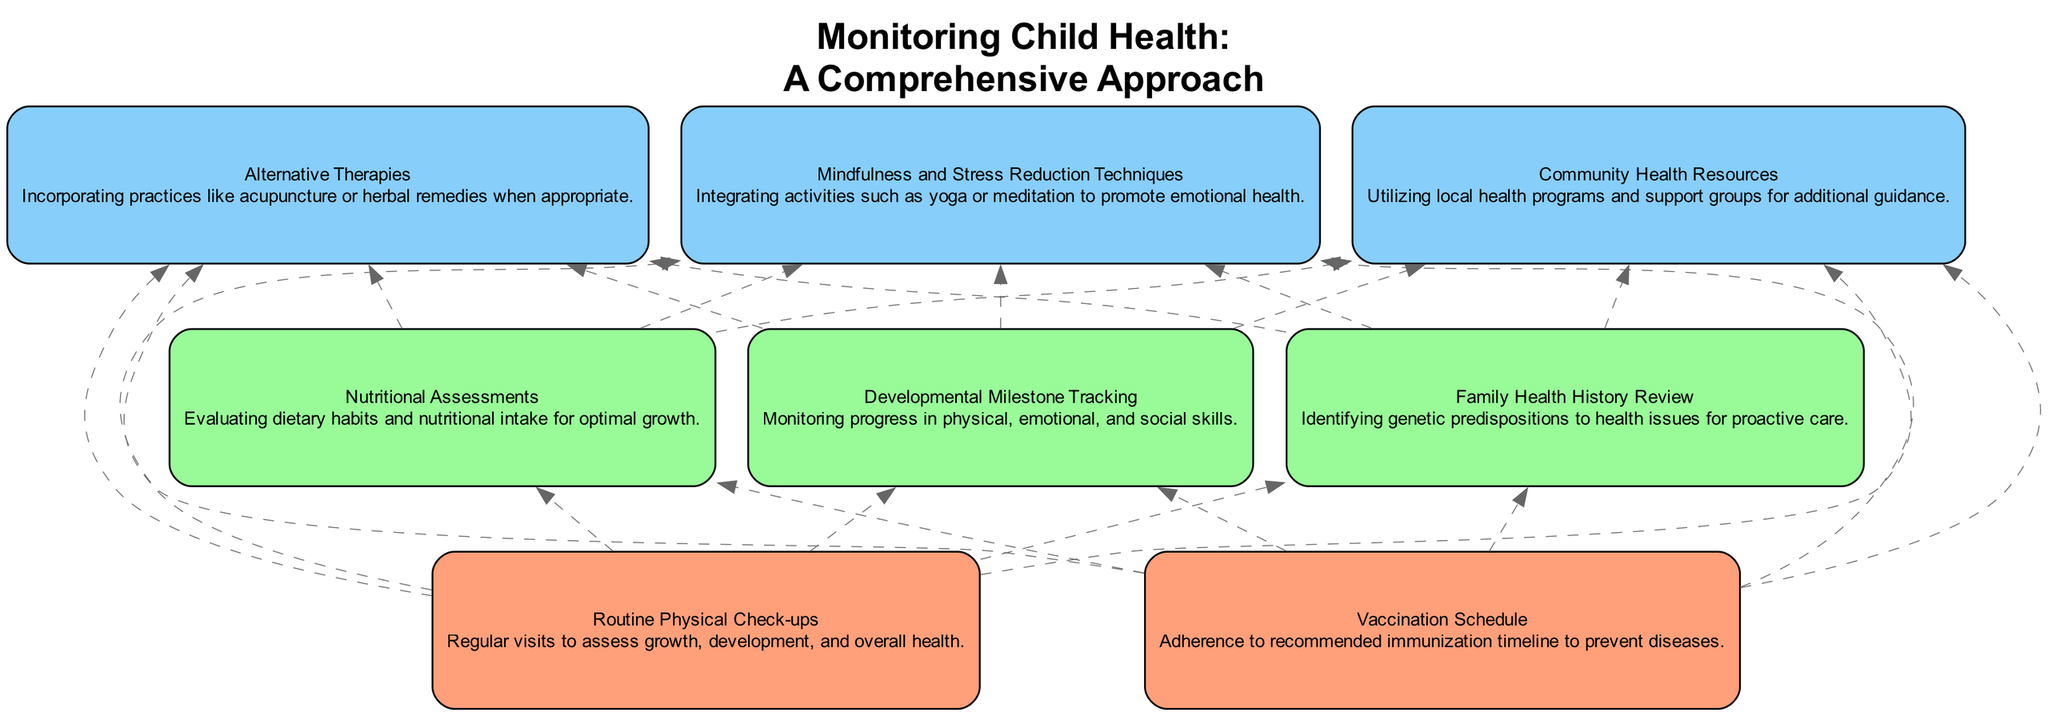What are the two primary components at level 1? The first level of the diagram contains two components: "Routine Physical Check-ups" and "Vaccination Schedule." These components are listed separately and are foundational to monitoring child health.
Answer: Routine Physical Check-ups, Vaccination Schedule How many components are at level 3? In the diagram, there are three components at level 3: "Alternative Therapies," "Mindfulness and Stress Reduction Techniques," and "Community Health Resources." Each of these elements is a non-traditional health practice that supports child well-being.
Answer: 3 Which element connects to both "Nutritional Assessments" and "Developmental Milestone Tracking"? "Family Health History Review" is positioned at the same level as the other components and connects upwards to both "Nutritional Assessments" and "Developmental Milestone Tracking." This indicates that it is a step in evaluating child health that can relate to both areas.
Answer: Family Health History Review What is the relationship between "Routine Physical Check-ups" and "Alternative Therapies"? "Routine Physical Check-ups" is at level 1, while "Alternative Therapies" is at level 3. There's a dashed edge in the diagram indicating that "Routine Physical Check-ups" influences or connects to "Alternative Therapies" as part of a broader health monitoring approach.
Answer: Influences Which node has the most connections in this diagram? "Routine Physical Check-ups" has the most connections. It is linked to both levels above it, connecting to "Nutritional Assessments," "Developmental Milestone Tracking," and subsequently to elements related to alternative practices at level 3.
Answer: Routine Physical Check-ups How many total elements are present in the diagram? The diagram lists a total of eight elements which include all the nodes from levels 1, 2, and 3, indicating the comprehensive nature of monitoring child health practices.
Answer: 8 